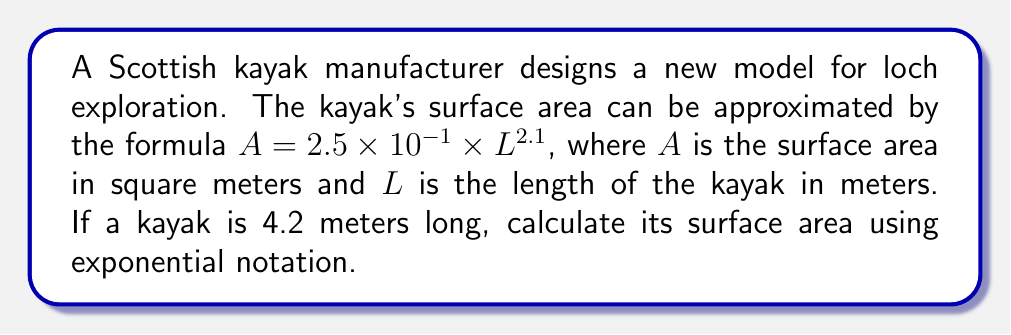Solve this math problem. To solve this problem, we'll follow these steps:

1) We're given the formula: $A = 2.5 \times 10^{-1} \times L^{2.1}$

2) We know that $L = 4.2$ meters. Let's substitute this into the formula:

   $A = 2.5 \times 10^{-1} \times (4.2)^{2.1}$

3) Let's calculate $(4.2)^{2.1}$ first:
   
   $(4.2)^{2.1} \approx 21.6815$

4) Now our equation looks like this:

   $A = 2.5 \times 10^{-1} \times 21.6815$

5) Multiply these numbers:

   $A = 5.420375$

6) To express this in exponential notation, we move the decimal point 0 places (as it's already between 1 and 10) and multiply by $10^0$:

   $A = 5.420375 \times 10^0$ square meters

This is our final answer in exponential notation.
Answer: $5.420375 \times 10^0$ m² 